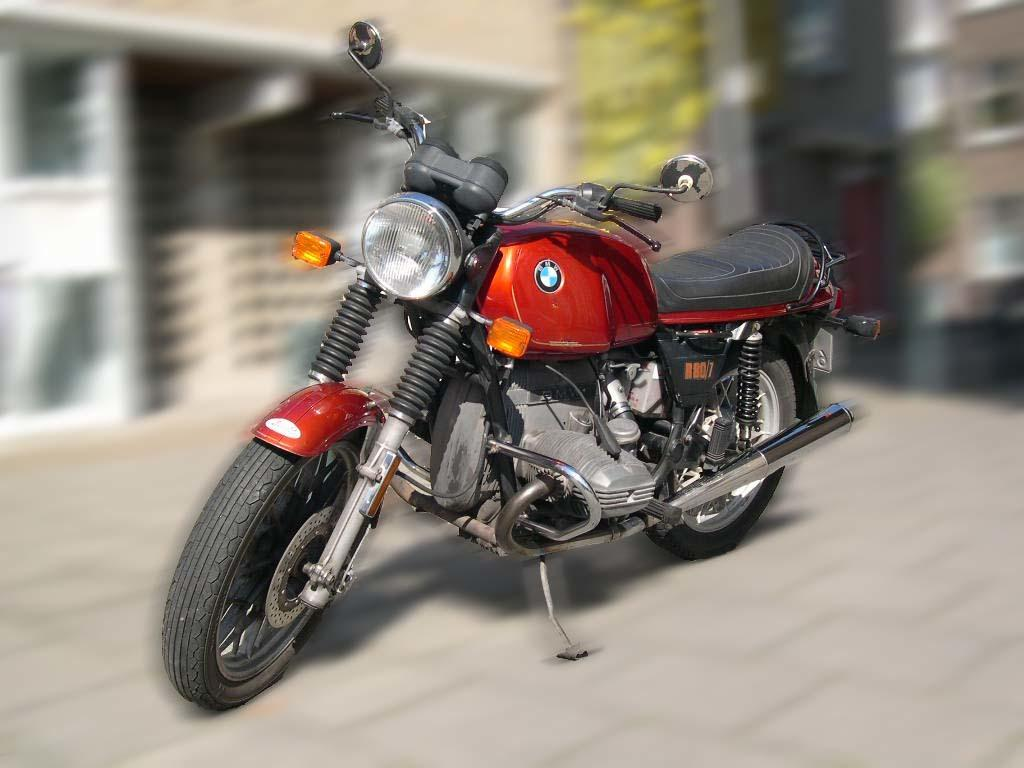What is the main subject of the image? The main subject of the image is a bike. Can you describe the colors of the bike? The bike is red and black in color. Is there any branding or logo on the bike? Yes, there is a logo on the bike. What can be seen in the foreground of the image? The path is visible in the image. How would you describe the background of the image? The background of the image is blurred. What time of day is depicted in the image, based on the hour shown on the bike's clock? There is no clock or hour visible on the bike in the image. How many people are in the crowd surrounding the bike in the image? There is no crowd present in the image; it only features the bike and the path. 